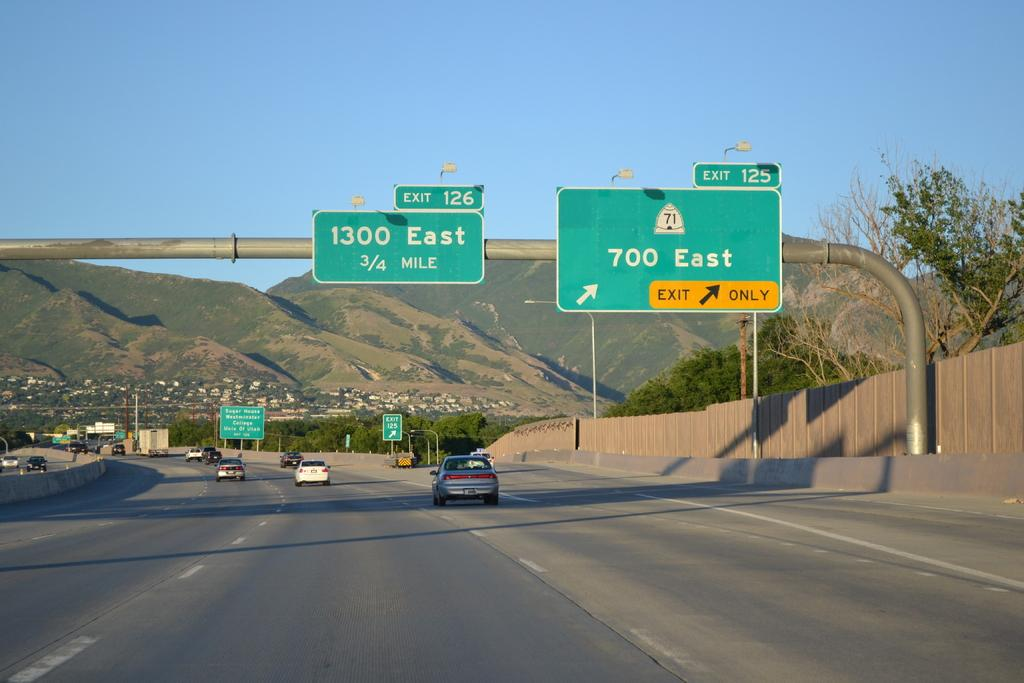<image>
Present a compact description of the photo's key features. Road signs showing that 700 east is to the right. 